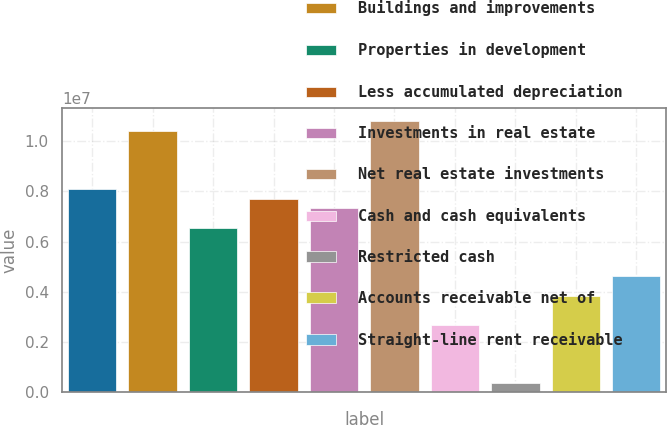<chart> <loc_0><loc_0><loc_500><loc_500><bar_chart><fcel>Land<fcel>Buildings and improvements<fcel>Properties in development<fcel>Less accumulated depreciation<fcel>Investments in real estate<fcel>Net real estate investments<fcel>Cash and cash equivalents<fcel>Restricted cash<fcel>Accounts receivable net of<fcel>Straight-line rent receivable<nl><fcel>8.09099e+06<fcel>1.04024e+07<fcel>6.55007e+06<fcel>7.70576e+06<fcel>7.32053e+06<fcel>1.07876e+07<fcel>2.69777e+06<fcel>386384<fcel>3.85346e+06<fcel>4.62392e+06<nl></chart> 